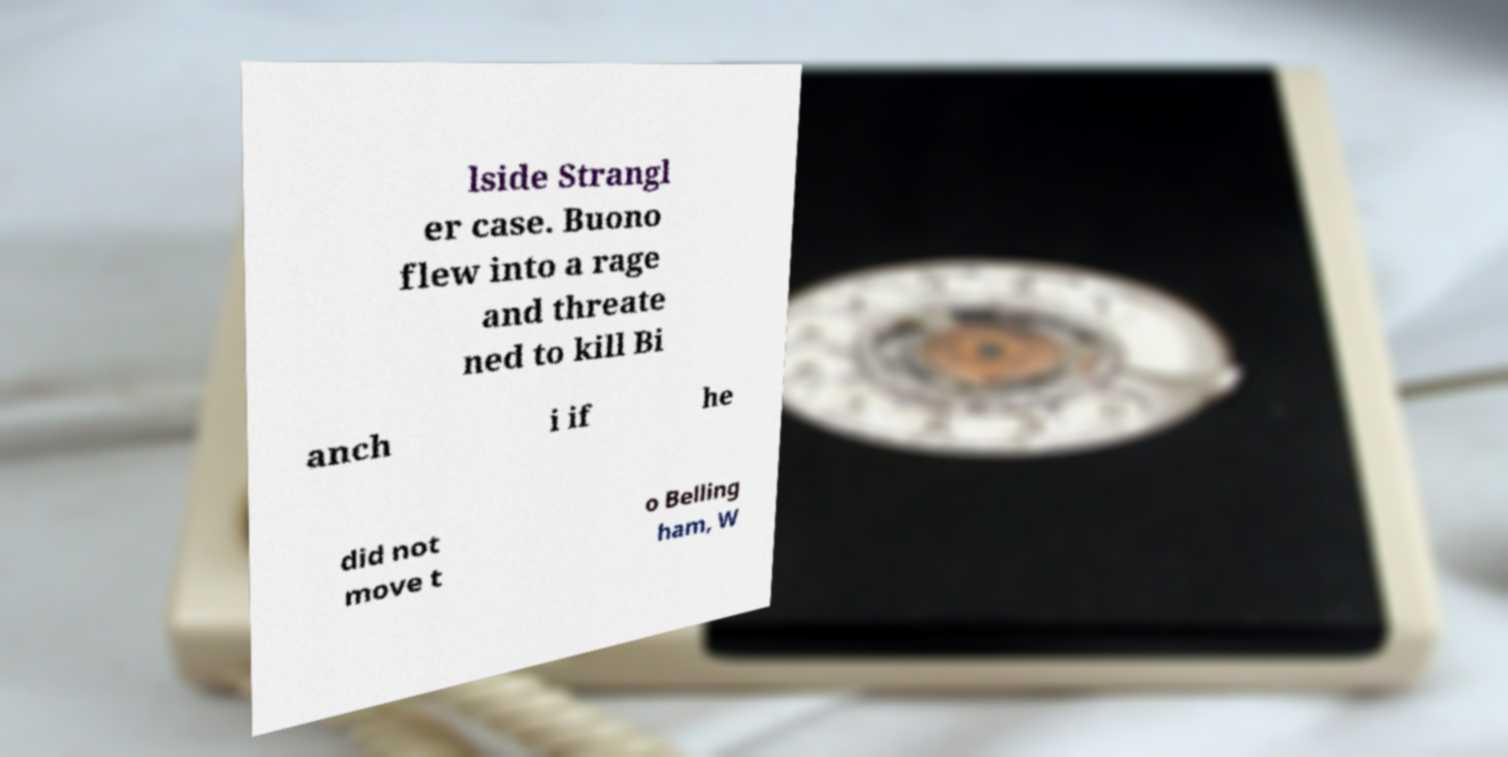Could you extract and type out the text from this image? lside Strangl er case. Buono flew into a rage and threate ned to kill Bi anch i if he did not move t o Belling ham, W 